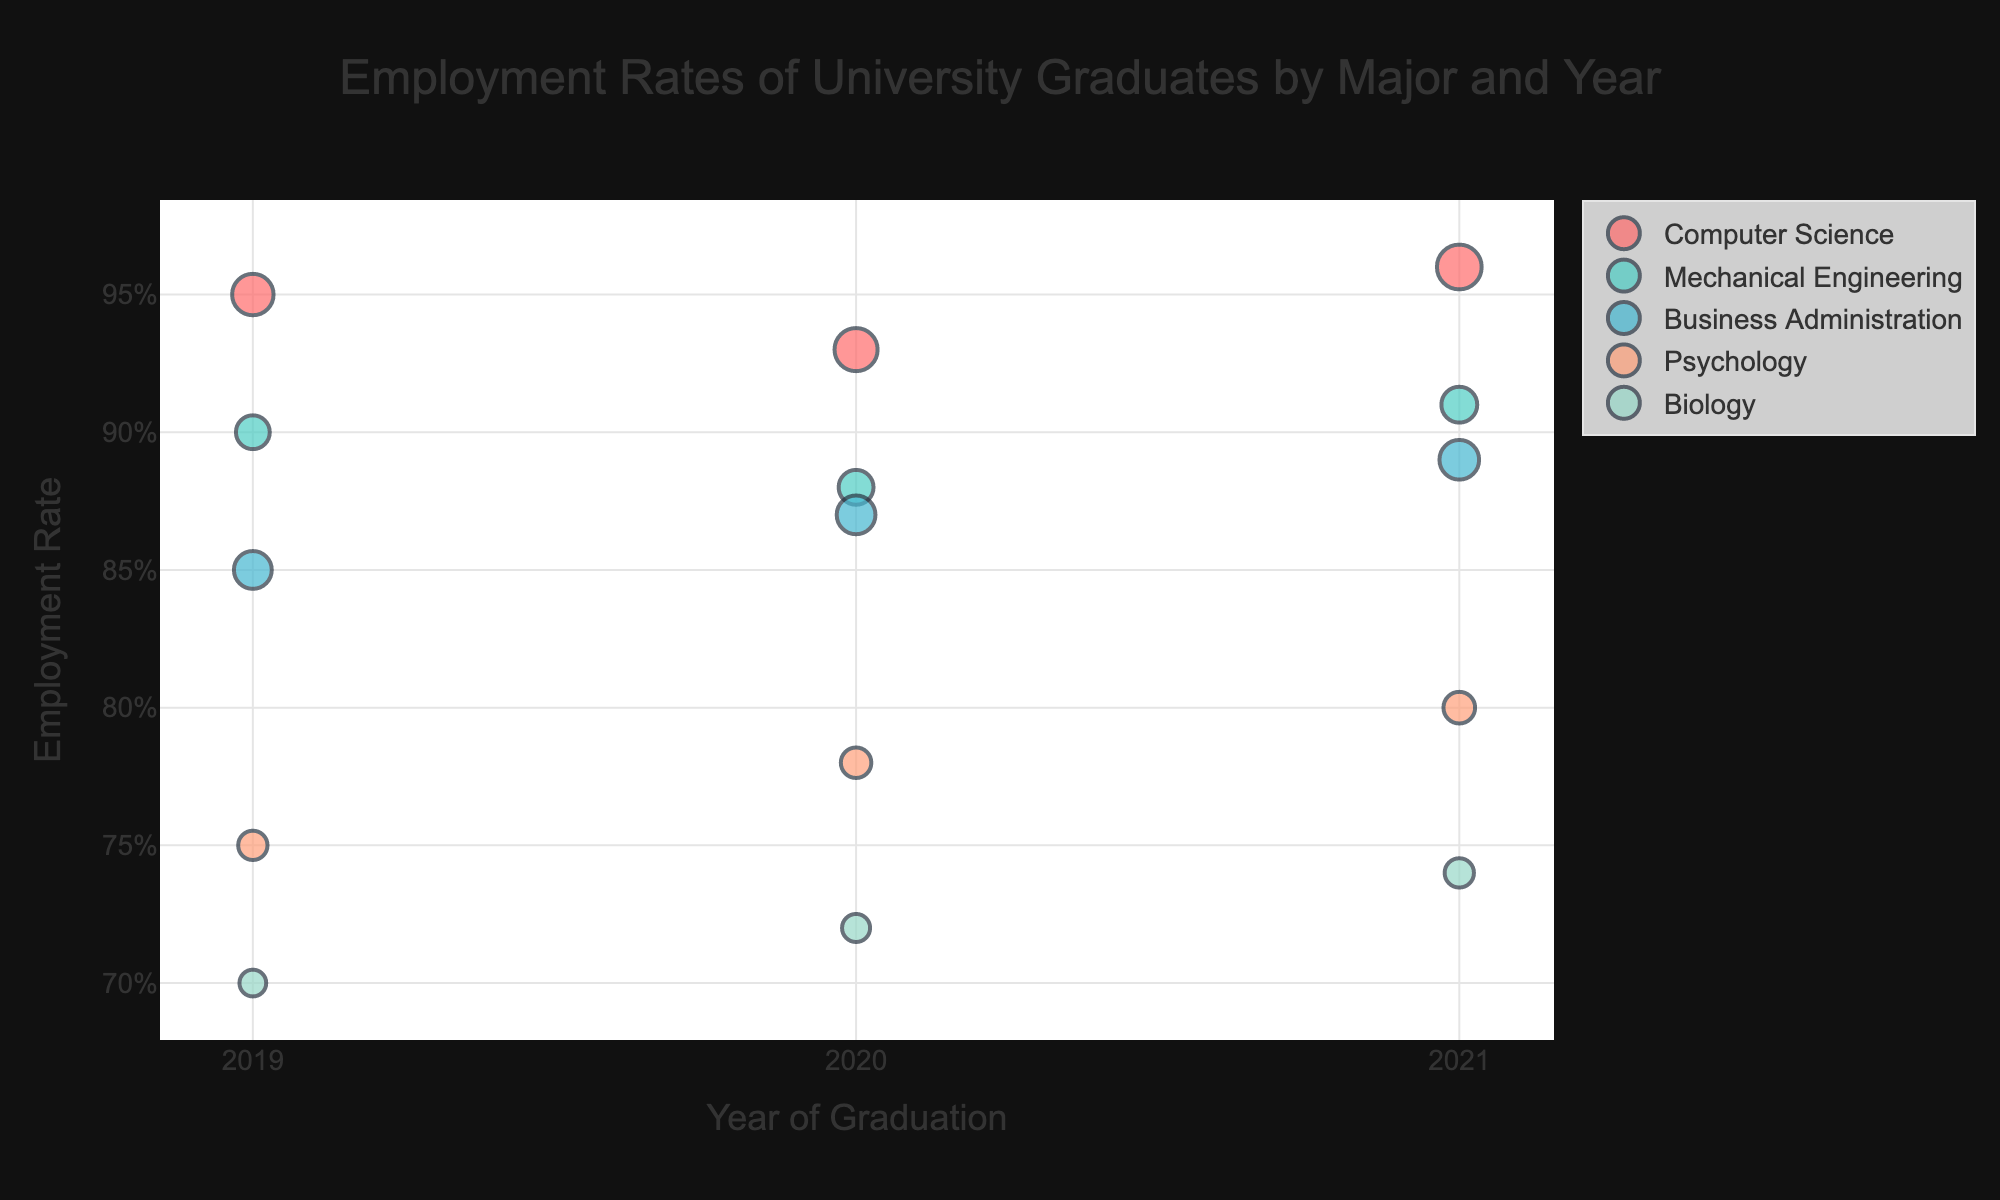What's the title of the chart? The title of the chart is displayed at the top and reads "Employment Rates of University Graduates by Major and Year".
Answer: Employment Rates of University Graduates by Major and Year What are the x-axis and y-axis labels? The x-axis label is "Year of Graduation" and the y-axis label is "Employment Rate".
Answer: Year of Graduation, Employment Rate How many majors are displayed in the chart? The chart displays five majors, each represented by different colored bubbles.
Answer: Five Which major had the highest employment rate in 2021? To determine this, look at the bubbles for the year 2021 and compare the employment rates. Computer Science has the highest employment rate at 96%.
Answer: Computer Science What is the average employment rate for Mechanical Engineering for the years shown? The employment rates for Mechanical Engineering are 90%, 88%, and 91% for 2019, 2020, and 2021 respectively. Sum these up and divide by 3: (0.90 + 0.88 + 0.91) / 3 = 0.8967, or 89.67%.
Answer: 89.67% Compare the employment rates of Business Administration and Psychology in 2019. Which one was higher? The employment rate of Business Administration in 2019 was 85%, and for Psychology, it was 75%. Business Administration had a higher employment rate.
Answer: Business Administration Which major showed the largest increase in employment rate from 2019 to 2021? Calculate the difference between 2021 and 2019 employment rates for each major. Psychology showed the largest increase, from 75% in 2019 to 80% in 2021, an increase of 5%.
Answer: Psychology How is the number of graduates represented in the chart? The number of graduates is represented by the size of the bubbles, with larger bubbles indicating a higher number of graduates.
Answer: By bubble size Which year had the highest employment rate for Biology graduates? Compare the employment rates for Biology across 2019 (70%), 2020 (72%), and 2021 (74%). The highest employment rate occurred in 2021 at 74%.
Answer: 2021 